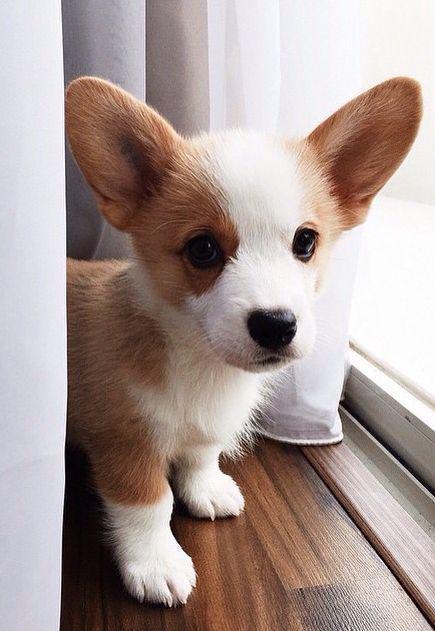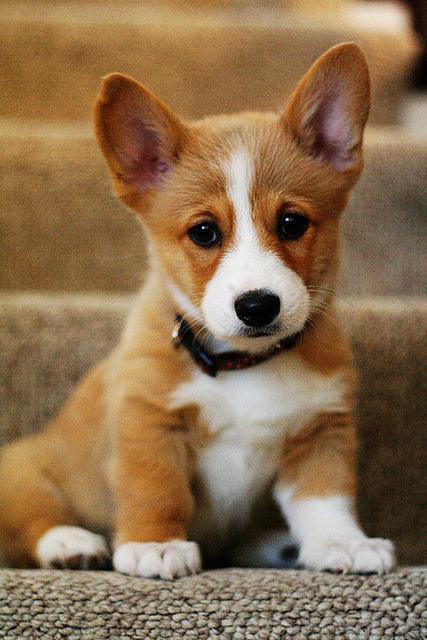The first image is the image on the left, the second image is the image on the right. Given the left and right images, does the statement "There are three dogs." hold true? Answer yes or no. No. The first image is the image on the left, the second image is the image on the right. Assess this claim about the two images: "One image contains twice as many dogs as the other image and includes a dog standing on all fours facing forward.". Correct or not? Answer yes or no. No. 